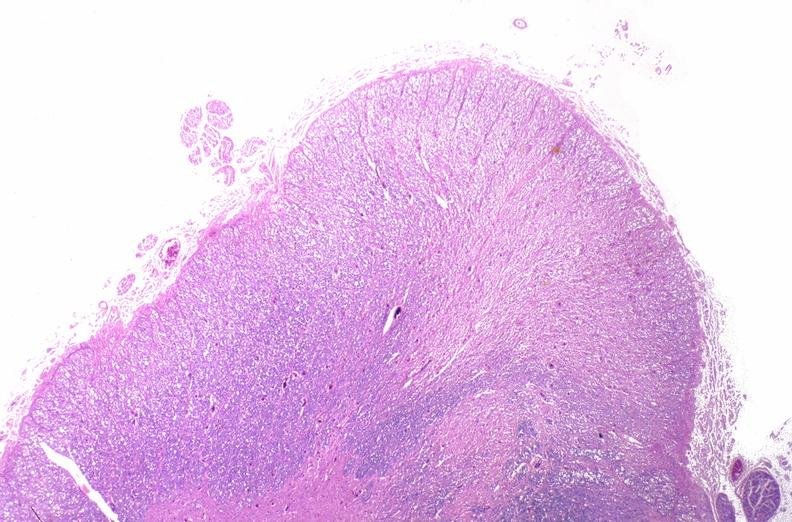what does this image show?
Answer the question using a single word or phrase. Spinal cord injury due to vertebral column trauma 